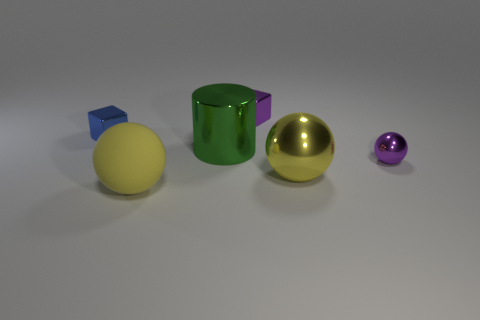Add 4 small purple spheres. How many objects exist? 10 Subtract all blocks. How many objects are left? 4 Subtract all matte spheres. Subtract all tiny blue shiny things. How many objects are left? 4 Add 6 blue things. How many blue things are left? 7 Add 4 metallic cubes. How many metallic cubes exist? 6 Subtract 0 cyan blocks. How many objects are left? 6 